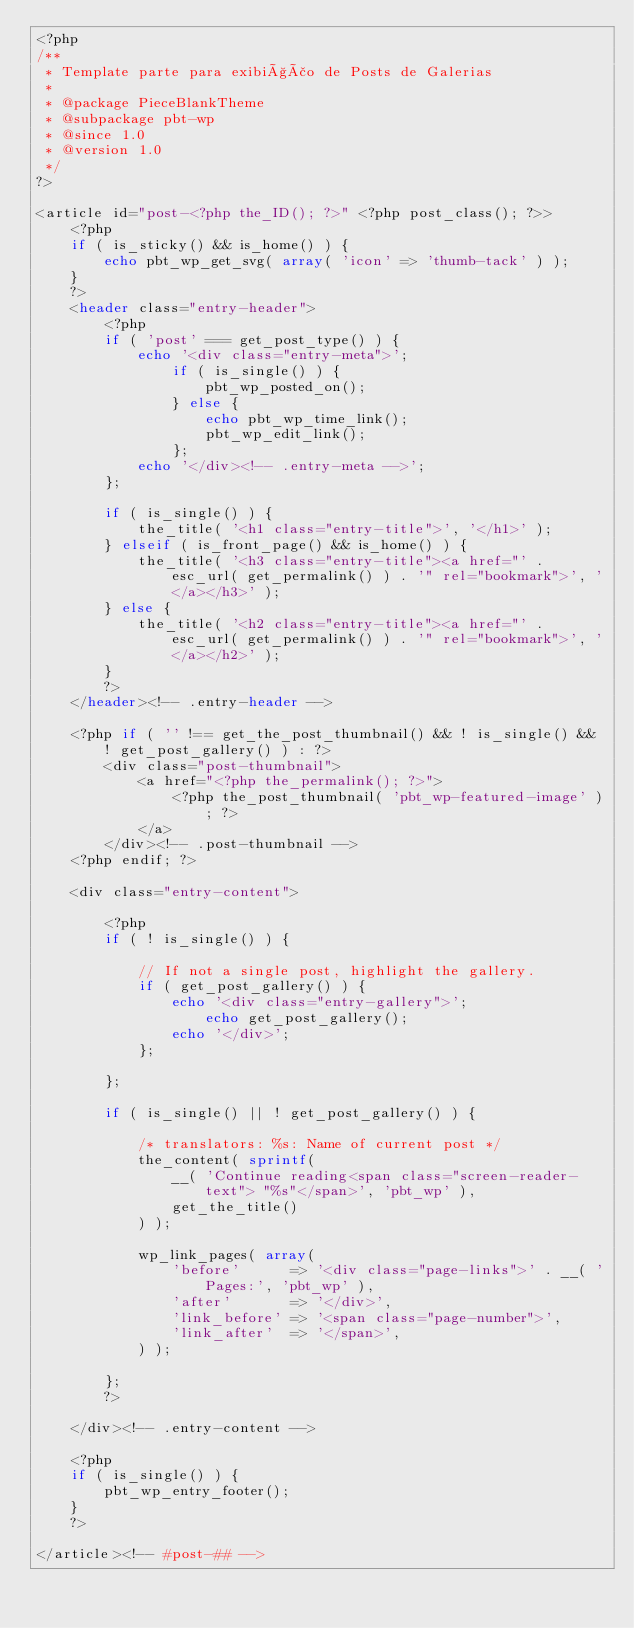<code> <loc_0><loc_0><loc_500><loc_500><_PHP_><?php
/**
 * Template parte para exibição de Posts de Galerias
 *
 * @package PieceBlankTheme
 * @subpackage pbt-wp
 * @since 1.0
 * @version 1.0
 */
?>

<article id="post-<?php the_ID(); ?>" <?php post_class(); ?>>
	<?php
	if ( is_sticky() && is_home() ) {
		echo pbt_wp_get_svg( array( 'icon' => 'thumb-tack' ) );
	}
	?>
	<header class="entry-header">
		<?php
		if ( 'post' === get_post_type() ) {
			echo '<div class="entry-meta">';
				if ( is_single() ) {
					pbt_wp_posted_on();
				} else {
					echo pbt_wp_time_link();
					pbt_wp_edit_link();
				};
			echo '</div><!-- .entry-meta -->';
		};

		if ( is_single() ) {
			the_title( '<h1 class="entry-title">', '</h1>' );
		} elseif ( is_front_page() && is_home() ) {
			the_title( '<h3 class="entry-title"><a href="' . esc_url( get_permalink() ) . '" rel="bookmark">', '</a></h3>' );
		} else {
			the_title( '<h2 class="entry-title"><a href="' . esc_url( get_permalink() ) . '" rel="bookmark">', '</a></h2>' );
		}
		?>
	</header><!-- .entry-header -->

	<?php if ( '' !== get_the_post_thumbnail() && ! is_single() && ! get_post_gallery() ) : ?>
		<div class="post-thumbnail">
			<a href="<?php the_permalink(); ?>">
				<?php the_post_thumbnail( 'pbt_wp-featured-image' ); ?>
			</a>
		</div><!-- .post-thumbnail -->
	<?php endif; ?>

	<div class="entry-content">

		<?php
		if ( ! is_single() ) {

			// If not a single post, highlight the gallery.
			if ( get_post_gallery() ) {
				echo '<div class="entry-gallery">';
					echo get_post_gallery();
				echo '</div>';
			};

		};

		if ( is_single() || ! get_post_gallery() ) {

			/* translators: %s: Name of current post */
			the_content( sprintf(
				__( 'Continue reading<span class="screen-reader-text"> "%s"</span>', 'pbt_wp' ),
				get_the_title()
			) );

			wp_link_pages( array(
				'before'      => '<div class="page-links">' . __( 'Pages:', 'pbt_wp' ),
				'after'       => '</div>',
				'link_before' => '<span class="page-number">',
				'link_after'  => '</span>',
			) );

		};
		?>

	</div><!-- .entry-content -->

	<?php
	if ( is_single() ) {
		pbt_wp_entry_footer();
	}
	?>

</article><!-- #post-## -->
</code> 